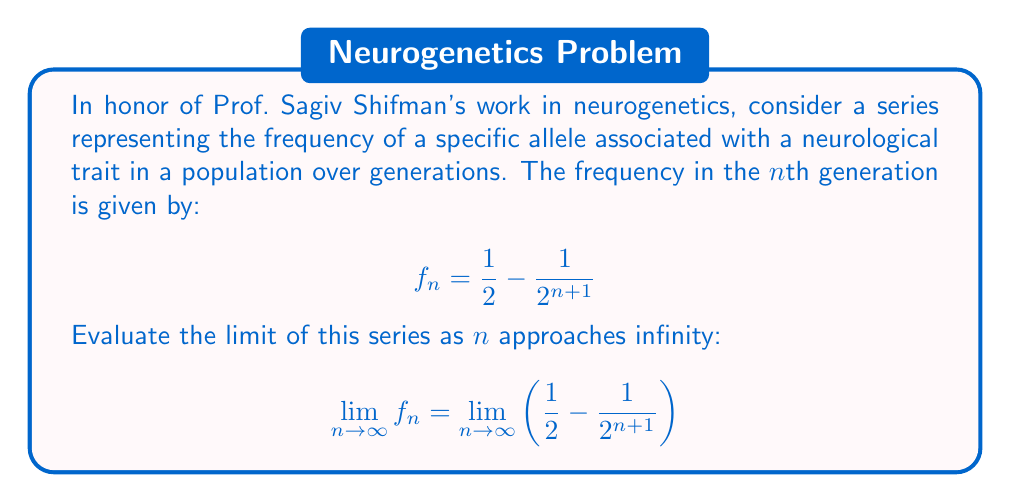Give your solution to this math problem. To evaluate this limit, we'll follow these steps:

1) First, let's examine the general term of the series:
   $$f_n = \frac{1}{2} - \frac{1}{2^{n+1}}$$

2) As n approaches infinity, we need to consider what happens to each part of this expression:

   a) The first term, $\frac{1}{2}$, is constant and doesn't change as n increases.

   b) For the second term, $\frac{1}{2^{n+1}}$, as n approaches infinity, the denominator becomes increasingly large.

3) Let's examine the limit of the second term:
   $$\lim_{n \to \infty} \frac{1}{2^{n+1}} = 0$$
   This is because any number raised to an increasingly large power in the denominator will approach zero.

4) Now, we can evaluate the limit of the entire expression:
   $$\lim_{n \to \infty} f_n = \lim_{n \to \infty} \left(\frac{1}{2} - \frac{1}{2^{n+1}}\right)$$
   $$= \frac{1}{2} - \lim_{n \to \infty} \frac{1}{2^{n+1}}$$
   $$= \frac{1}{2} - 0 = \frac{1}{2}$$

5) Therefore, the limit of the series as n approaches infinity is $\frac{1}{2}$.

In the context of population genetics, this result suggests that the frequency of the allele stabilizes at 50% in the population over many generations, assuming no other evolutionary forces are at play.
Answer: $$\lim_{n \to \infty} f_n = \frac{1}{2}$$ 